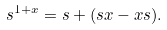<formula> <loc_0><loc_0><loc_500><loc_500>s ^ { 1 + x } = s + ( s x - x s ) .</formula> 